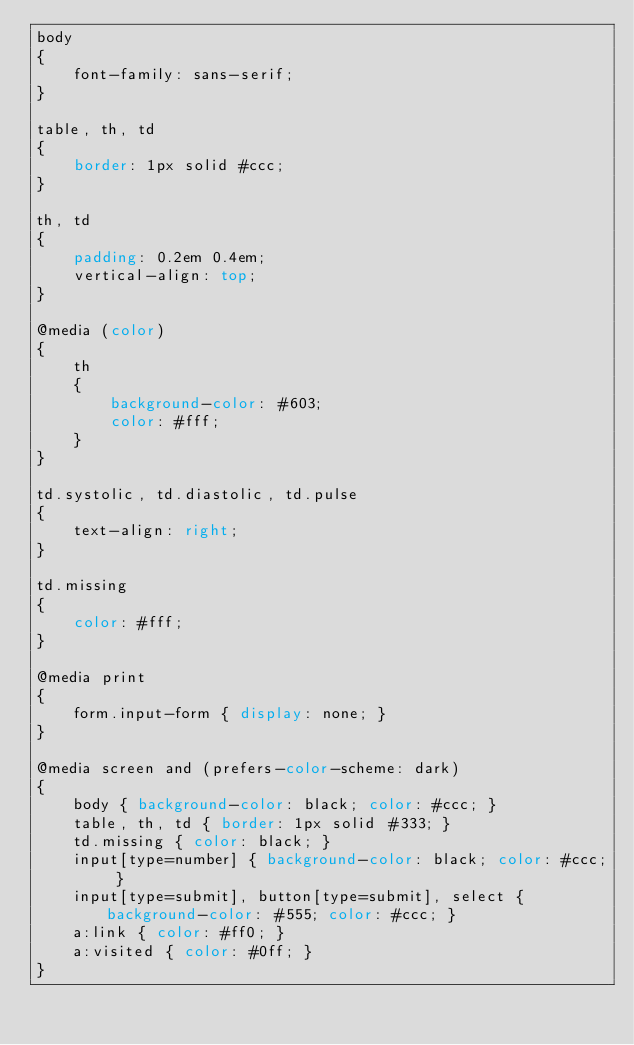<code> <loc_0><loc_0><loc_500><loc_500><_CSS_>body
{
    font-family: sans-serif;
}

table, th, td
{
    border: 1px solid #ccc;
}

th, td
{
    padding: 0.2em 0.4em;
    vertical-align: top;
}

@media (color)
{
    th
    {
        background-color: #603;
        color: #fff;
    }
}

td.systolic, td.diastolic, td.pulse
{
    text-align: right;
}

td.missing
{
    color: #fff;
}

@media print
{
    form.input-form { display: none; }
}

@media screen and (prefers-color-scheme: dark)
{
    body { background-color: black; color: #ccc; }
    table, th, td { border: 1px solid #333; }
    td.missing { color: black; }
    input[type=number] { background-color: black; color: #ccc; }
    input[type=submit], button[type=submit], select { background-color: #555; color: #ccc; }
    a:link { color: #ff0; }
    a:visited { color: #0ff; }
}
</code> 